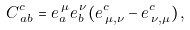Convert formula to latex. <formula><loc_0><loc_0><loc_500><loc_500>C ^ { c } _ { \, a b } = e _ { a } ^ { \, \mu } e _ { b } ^ { \, \nu } ( e ^ { c } _ { \, \mu , \nu } - e ^ { c } _ { \, \nu , \mu } ) \, ,</formula> 